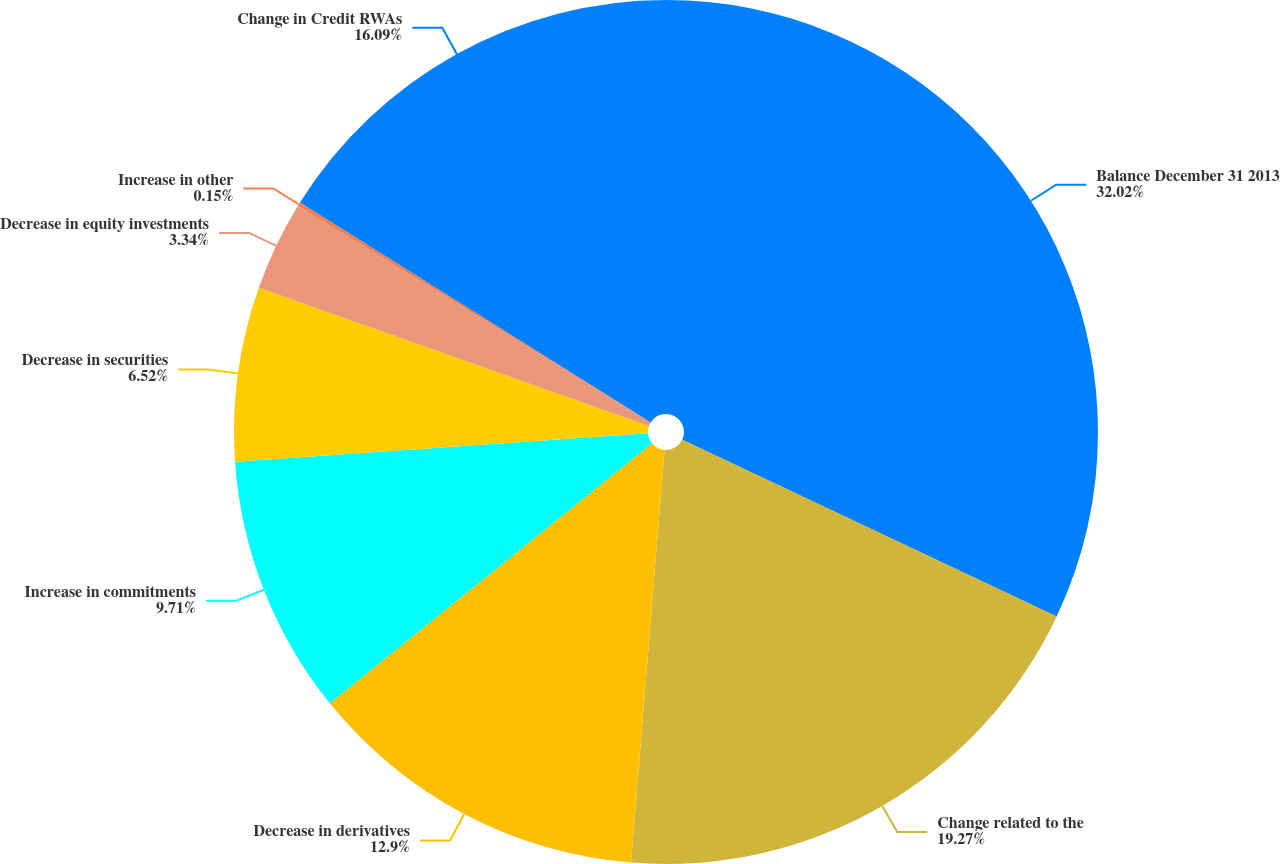Convert chart. <chart><loc_0><loc_0><loc_500><loc_500><pie_chart><fcel>Balance December 31 2013<fcel>Change related to the<fcel>Decrease in derivatives<fcel>Increase in commitments<fcel>Decrease in securities<fcel>Decrease in equity investments<fcel>Increase in other<fcel>Change in Credit RWAs<nl><fcel>32.02%<fcel>19.27%<fcel>12.9%<fcel>9.71%<fcel>6.52%<fcel>3.34%<fcel>0.15%<fcel>16.09%<nl></chart> 